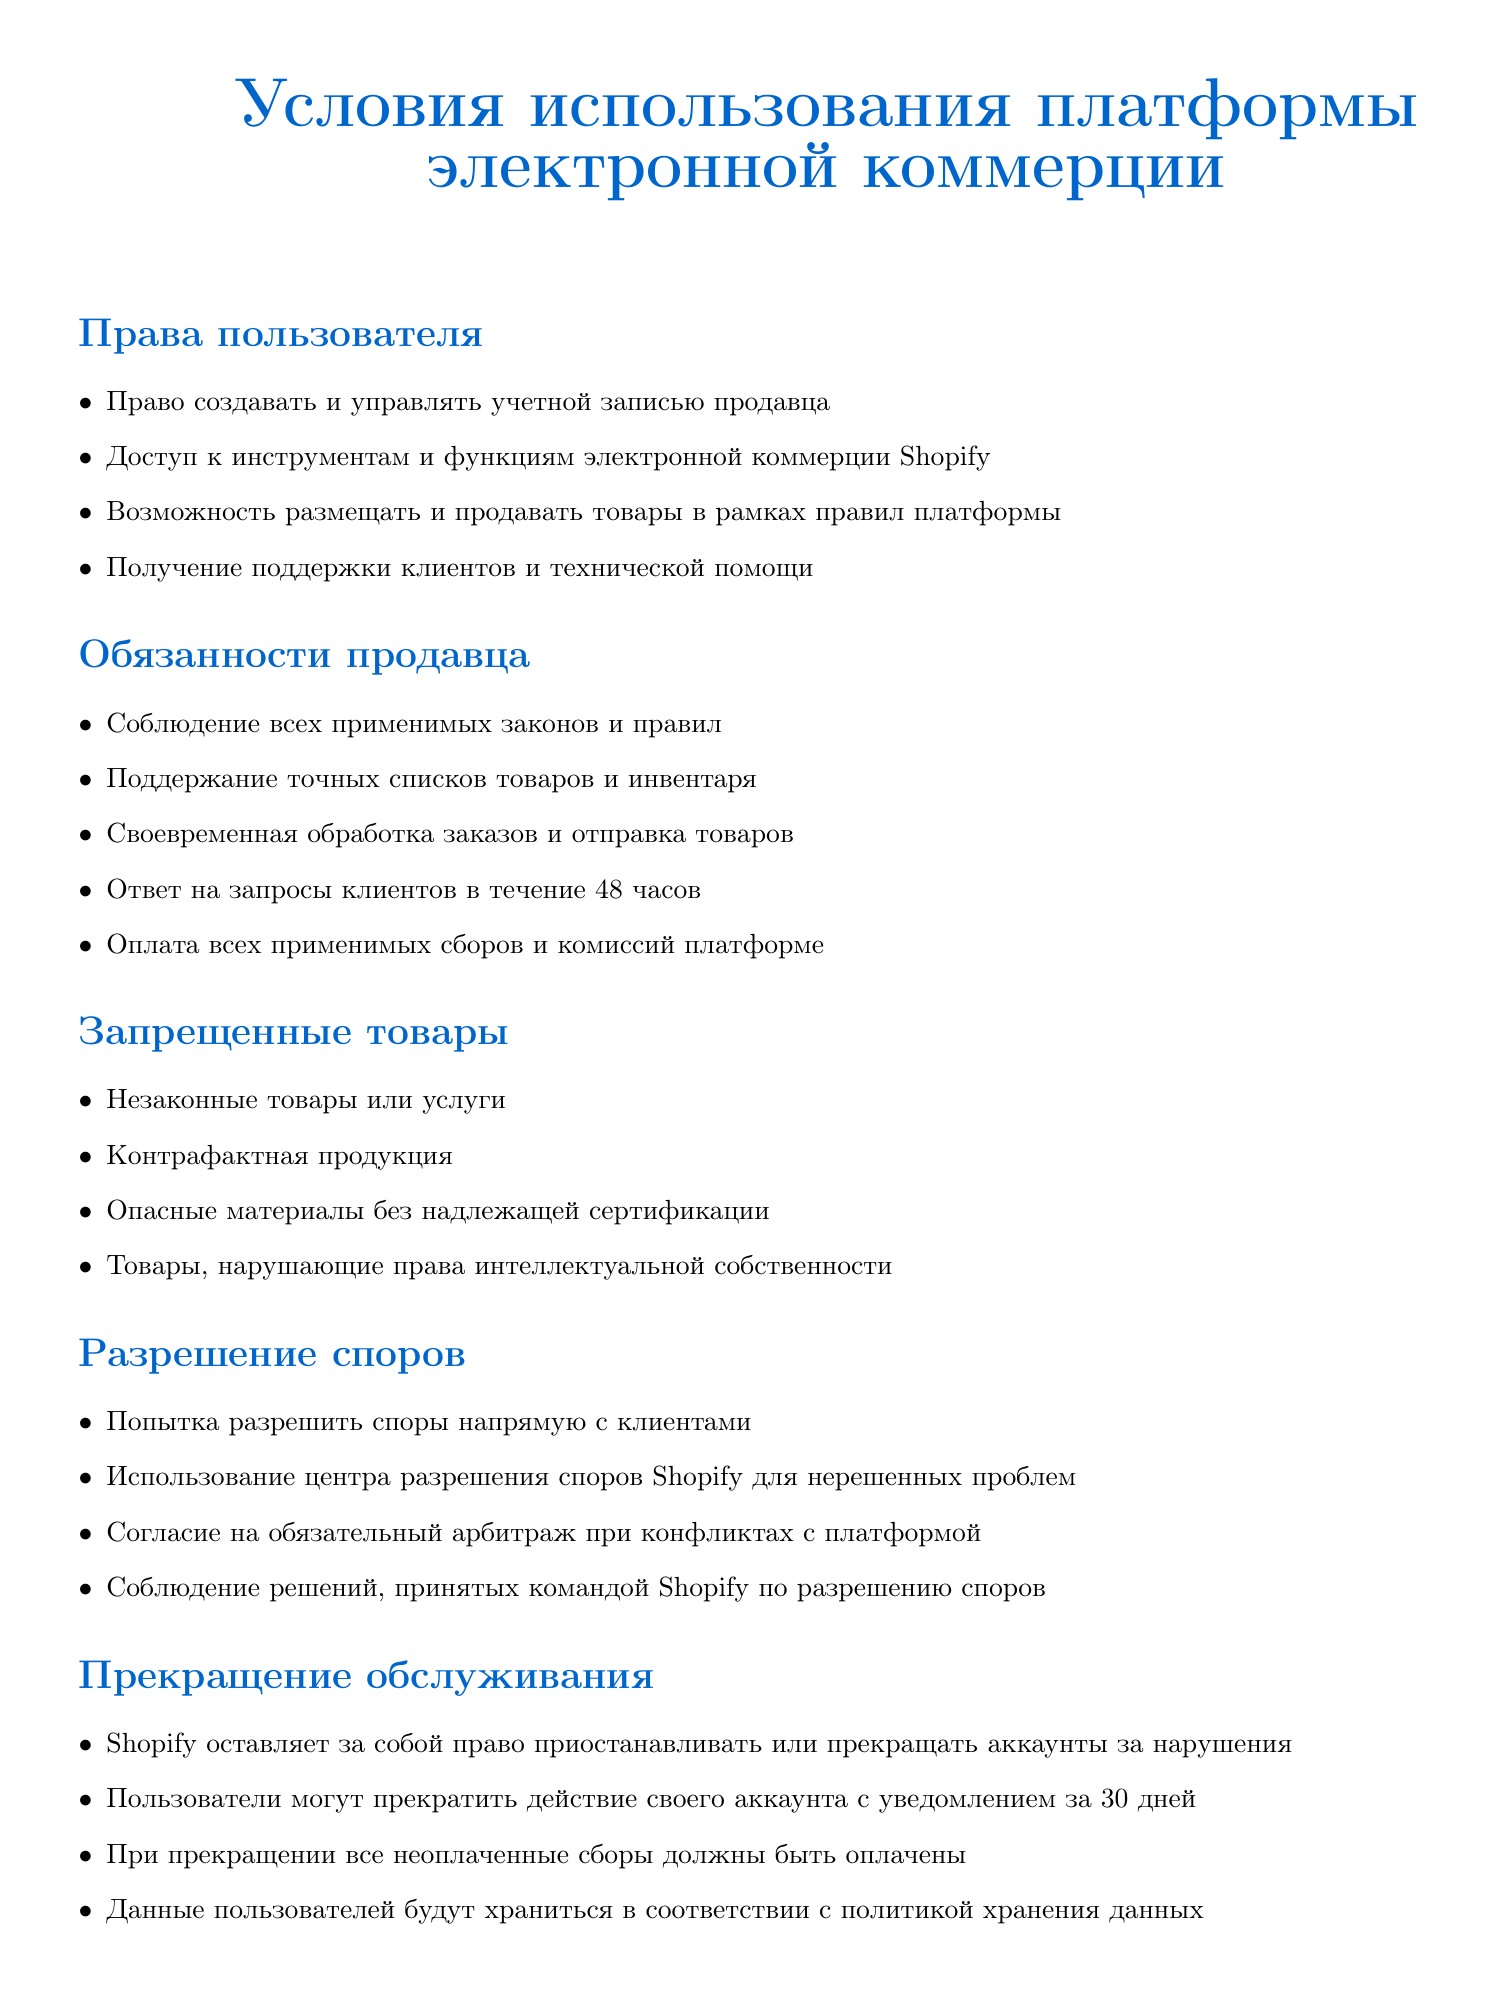что пользователь может делать на платформе? Пользователь может создавать и управлять учетной записью продавца, иметь доступ к инструментам и функциям электронной коммерции, размещать и продавать товары, а также получать поддержку клиентов и техническую помощь.
Answer: создавать и управлять учетной записью продавца какие обязательства у продавца? Продавец обязан соблюдать все применимые законы и правила, поддерживать точные списки товаров и инвентаря, обрабатывать заказы, отвечать на запросы клиентов, и оплачивать все сборы.
Answer: соблюдать все применимые законы и правила что происходит с аккаунтом, если есть нарушения? Если будут нарушения, Shopify оставляет за собой право приостановить или прекратить аккаунты.
Answer: приостановить или прекратить в течение какого времени продавец должен отвечать на запросы клиентов? Продавец должен ответить на запросы клиентов в течение 48 часов.
Answer: 48 часов что будет с неоплаченными сборами при прекращении аккаунта? При прекращении все неоплаченные сборы должны быть оплачены.
Answer: оплачены как разрешаются споры с клиентами? Споры следует пытаться разрешить напрямую с клиентами, а затем использовать центр разрешения споров Shopify для нерешенных проблем.
Answer: напрямую с клиентами что включают в себя запрещенные товары? Запрещенные товары включают незаконные товары, контрафактную продукцию, опасные материалы без сертификации, товары, нарушающие права интеллектуальной собственности.
Answer: незаконные товары или услуги может ли пользователь прекратить действие своего аккаунта? Да, пользователи могут прекратить действие своего аккаунта с уведомлением за 30 дней.
Answer: с уведомлением за 30 дней 